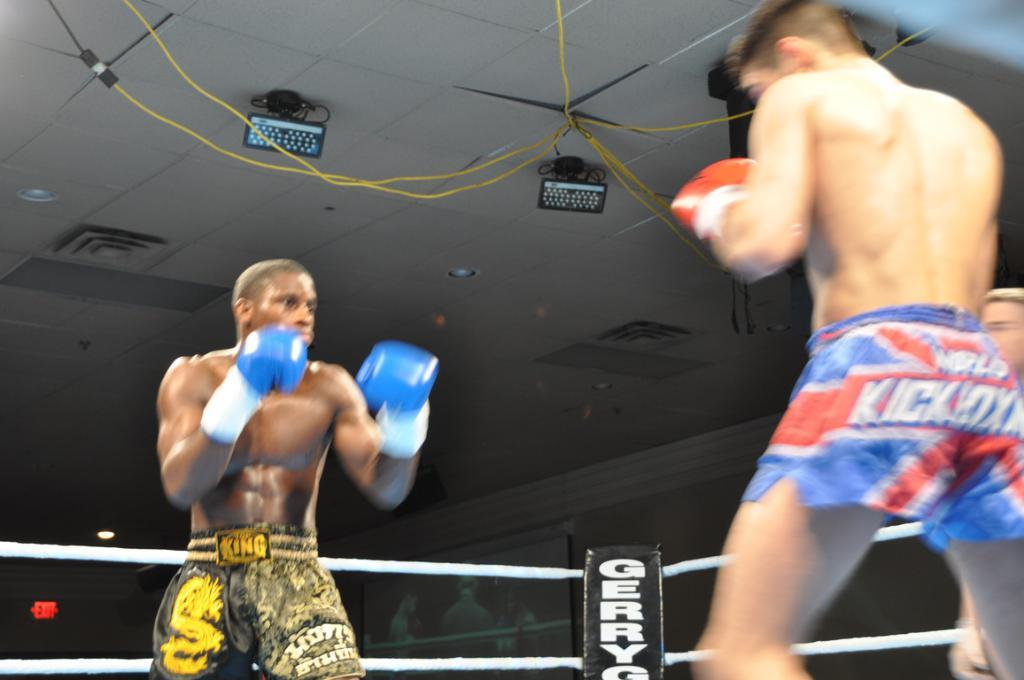<image>
Render a clear and concise summary of the photo. The fighter in the black shorts has the word king on his belt. 